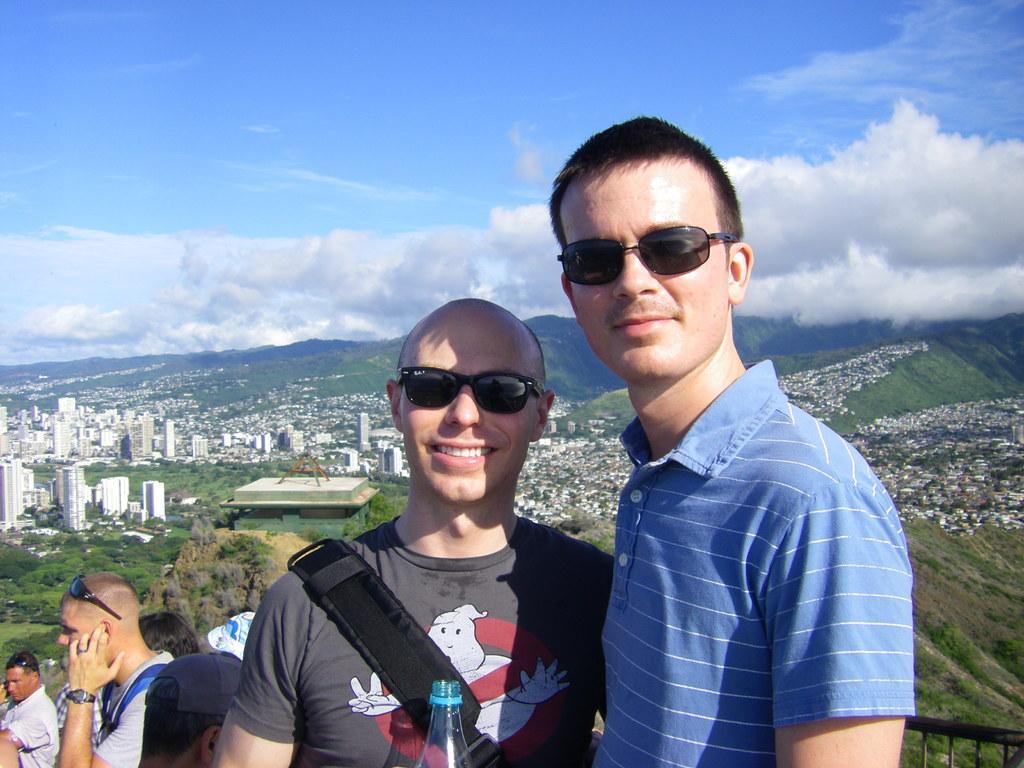Could you give a brief overview of what you see in this image? In this image I can see few people wearing bag and glasses. Back I can see a trees,buildings and mountain. The sky is in blue and white color. 